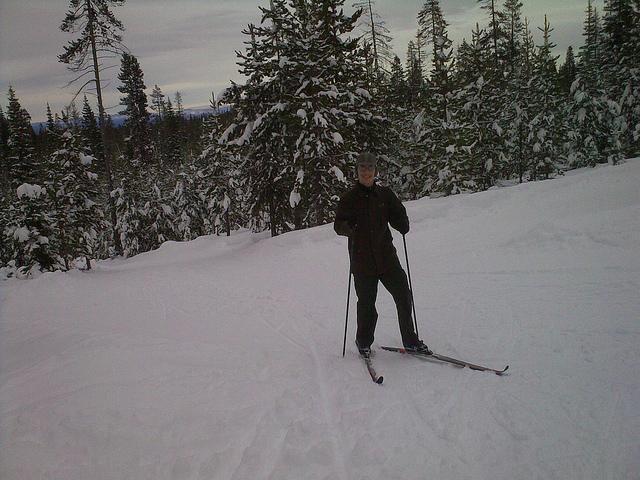How many skateboarders have stopped to take a break?
Give a very brief answer. 0. 